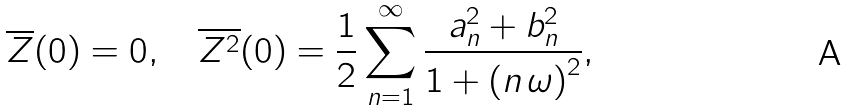Convert formula to latex. <formula><loc_0><loc_0><loc_500><loc_500>\overline { Z } ( 0 ) = 0 , \quad \overline { Z ^ { 2 } } ( 0 ) = \frac { 1 } { 2 } \sum _ { n = 1 } ^ { \infty } \frac { a _ { n } ^ { 2 } + b _ { n } ^ { 2 } } { 1 + \left ( n \, \omega \right ) ^ { 2 } } ,</formula> 